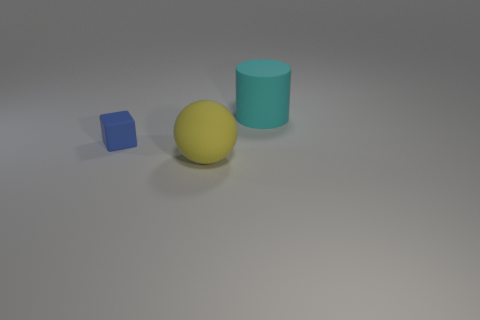Is there any other thing that has the same size as the blue object?
Provide a short and direct response. No. How many objects are objects that are to the left of the big yellow matte object or matte spheres?
Make the answer very short. 2. The ball that is made of the same material as the large cylinder is what color?
Provide a short and direct response. Yellow. Is there a blue block of the same size as the yellow rubber thing?
Ensure brevity in your answer.  No. What is the color of the rubber thing that is on the right side of the small cube and behind the large matte ball?
Offer a terse response. Cyan. What is the shape of the object that is the same size as the cyan rubber cylinder?
Offer a very short reply. Sphere. There is a thing that is to the right of the sphere; is its size the same as the small block?
Make the answer very short. No. There is a thing that is behind the big sphere and on the left side of the large rubber cylinder; what is its size?
Your answer should be compact. Small. How many other objects are the same material as the large yellow thing?
Offer a terse response. 2. What size is the rubber object to the left of the big sphere?
Ensure brevity in your answer.  Small. 